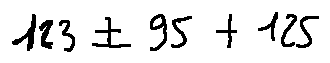Convert formula to latex. <formula><loc_0><loc_0><loc_500><loc_500>1 2 3 \pm 9 5 + 1 2 5</formula> 